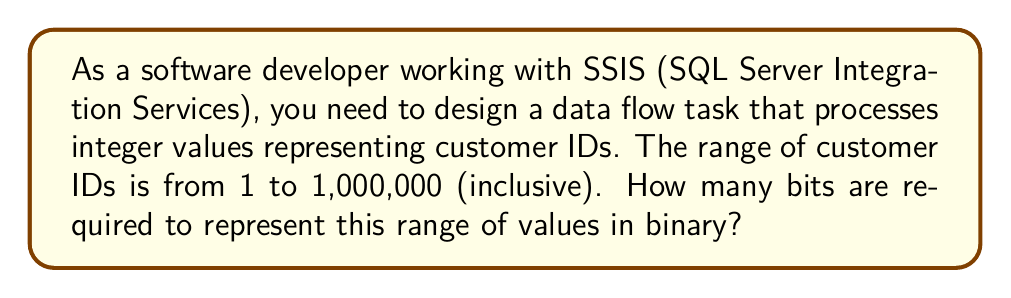Can you answer this question? To determine the number of bits required to represent a given range of values, we need to follow these steps:

1. Calculate the total number of distinct values in the range:
   $N = \text{max value} - \text{min value} + 1$
   $N = 1,000,000 - 1 + 1 = 1,000,000$

2. Find the smallest power of 2 that is greater than or equal to N:
   $2^n \geq N$, where n is the number of bits

3. We can use the logarithm (base 2) to find n:
   $n = \lceil \log_2(N) \rceil$

   Where $\lceil \cdot \rceil$ denotes the ceiling function (rounding up to the nearest integer).

4. Calculate:
   $\log_2(1,000,000) \approx 19.9315685693$

5. Apply the ceiling function:
   $\lceil 19.9315685693 \rceil = 20$

Therefore, we need 20 bits to represent the range of values from 1 to 1,000,000.

To verify:
$2^{19} = 524,288$ (not enough)
$2^{20} = 1,048,576$ (sufficient to represent 1,000,000 distinct values)

In SSIS, you would typically use a 32-bit integer (Int32) data type for this range, as it's the smallest standard integer type that can accommodate the required 20 bits.
Answer: 20 bits 